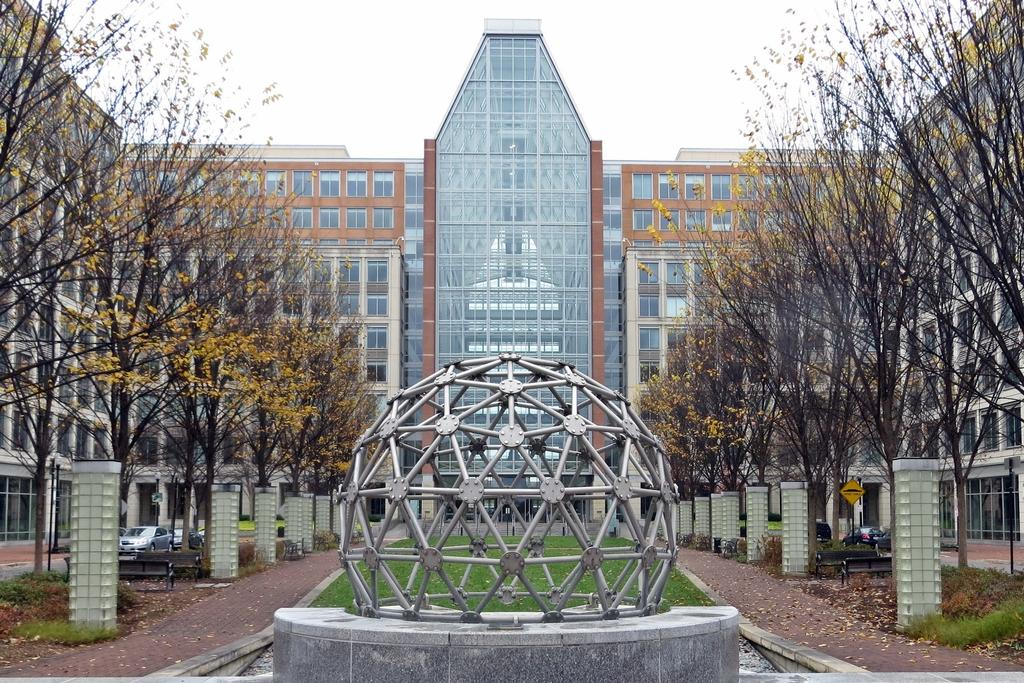What is the main structure on the platform in the image? There is a dome on a platform in the image. What type of vegetation can be seen in the image? There is grass in the image. What are the paths used for in the image? The paths are used for walking or moving around in the image. What are the poles used for in the image? The poles might be used for supporting signs or other structures in the image. What types of vehicles are present in the image? There are vehicles in the image, but their specific types are not mentioned. What type of trees can be seen in the image? There are trees in the image, but their specific types are not mentioned. What are the benches used for in the image? The benches are used for sitting or resting in the image. What information might be displayed on the signboard in the image? The signboard in the image might display directions, rules, or other information. What can be seen in the background of the image? The sky is visible in the background of the image. How many mice can be seen running on the dome in the image? There are no mice present in the image, and therefore no mice can be seen running on the dome. What type of light is emitted from the dome in the image? The image does not show any light being emitted from the dome, so it cannot be determined from the image. 